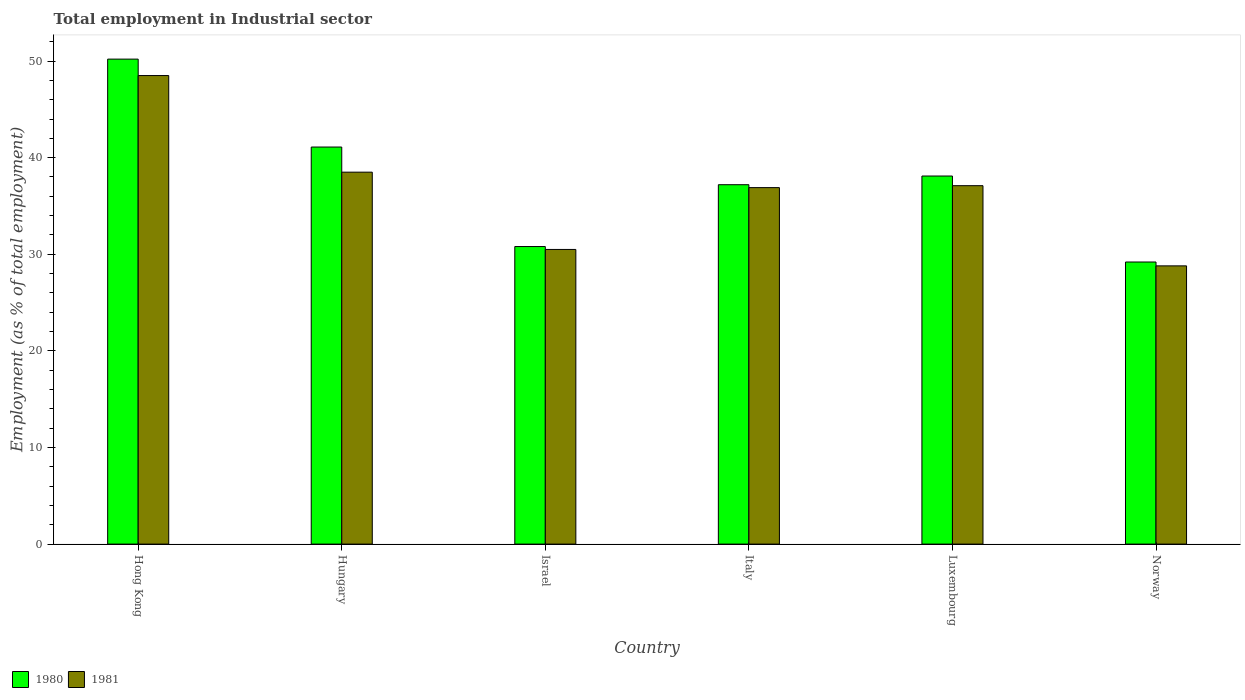How many different coloured bars are there?
Keep it short and to the point. 2. How many groups of bars are there?
Your response must be concise. 6. Are the number of bars per tick equal to the number of legend labels?
Your response must be concise. Yes. Are the number of bars on each tick of the X-axis equal?
Offer a very short reply. Yes. How many bars are there on the 6th tick from the left?
Your response must be concise. 2. How many bars are there on the 4th tick from the right?
Ensure brevity in your answer.  2. What is the employment in industrial sector in 1981 in Norway?
Offer a very short reply. 28.8. Across all countries, what is the maximum employment in industrial sector in 1980?
Provide a succinct answer. 50.2. Across all countries, what is the minimum employment in industrial sector in 1980?
Provide a short and direct response. 29.2. In which country was the employment in industrial sector in 1980 maximum?
Offer a very short reply. Hong Kong. In which country was the employment in industrial sector in 1981 minimum?
Make the answer very short. Norway. What is the total employment in industrial sector in 1980 in the graph?
Your answer should be compact. 226.6. What is the difference between the employment in industrial sector in 1981 in Hungary and that in Italy?
Make the answer very short. 1.6. What is the difference between the employment in industrial sector in 1980 in Luxembourg and the employment in industrial sector in 1981 in Norway?
Make the answer very short. 9.3. What is the average employment in industrial sector in 1980 per country?
Give a very brief answer. 37.77. What is the difference between the employment in industrial sector of/in 1981 and employment in industrial sector of/in 1980 in Hong Kong?
Give a very brief answer. -1.7. What is the ratio of the employment in industrial sector in 1981 in Israel to that in Luxembourg?
Your answer should be compact. 0.82. Is the employment in industrial sector in 1980 in Hungary less than that in Luxembourg?
Offer a terse response. No. Is the difference between the employment in industrial sector in 1981 in Italy and Norway greater than the difference between the employment in industrial sector in 1980 in Italy and Norway?
Provide a short and direct response. Yes. What is the difference between the highest and the second highest employment in industrial sector in 1980?
Make the answer very short. -9.1. What is the difference between the highest and the lowest employment in industrial sector in 1981?
Make the answer very short. 19.7. In how many countries, is the employment in industrial sector in 1981 greater than the average employment in industrial sector in 1981 taken over all countries?
Keep it short and to the point. 4. Is the sum of the employment in industrial sector in 1981 in Luxembourg and Norway greater than the maximum employment in industrial sector in 1980 across all countries?
Provide a succinct answer. Yes. What does the 2nd bar from the left in Italy represents?
Your answer should be very brief. 1981. Are all the bars in the graph horizontal?
Ensure brevity in your answer.  No. What is the difference between two consecutive major ticks on the Y-axis?
Keep it short and to the point. 10. Does the graph contain any zero values?
Your response must be concise. No. Where does the legend appear in the graph?
Your answer should be very brief. Bottom left. How many legend labels are there?
Your response must be concise. 2. How are the legend labels stacked?
Give a very brief answer. Horizontal. What is the title of the graph?
Offer a terse response. Total employment in Industrial sector. Does "1961" appear as one of the legend labels in the graph?
Provide a short and direct response. No. What is the label or title of the Y-axis?
Provide a short and direct response. Employment (as % of total employment). What is the Employment (as % of total employment) in 1980 in Hong Kong?
Your response must be concise. 50.2. What is the Employment (as % of total employment) in 1981 in Hong Kong?
Your answer should be compact. 48.5. What is the Employment (as % of total employment) of 1980 in Hungary?
Keep it short and to the point. 41.1. What is the Employment (as % of total employment) of 1981 in Hungary?
Provide a succinct answer. 38.5. What is the Employment (as % of total employment) of 1980 in Israel?
Provide a succinct answer. 30.8. What is the Employment (as % of total employment) in 1981 in Israel?
Offer a very short reply. 30.5. What is the Employment (as % of total employment) of 1980 in Italy?
Your response must be concise. 37.2. What is the Employment (as % of total employment) in 1981 in Italy?
Give a very brief answer. 36.9. What is the Employment (as % of total employment) in 1980 in Luxembourg?
Offer a terse response. 38.1. What is the Employment (as % of total employment) of 1981 in Luxembourg?
Your response must be concise. 37.1. What is the Employment (as % of total employment) in 1980 in Norway?
Keep it short and to the point. 29.2. What is the Employment (as % of total employment) of 1981 in Norway?
Provide a succinct answer. 28.8. Across all countries, what is the maximum Employment (as % of total employment) of 1980?
Keep it short and to the point. 50.2. Across all countries, what is the maximum Employment (as % of total employment) of 1981?
Provide a short and direct response. 48.5. Across all countries, what is the minimum Employment (as % of total employment) of 1980?
Give a very brief answer. 29.2. Across all countries, what is the minimum Employment (as % of total employment) in 1981?
Provide a short and direct response. 28.8. What is the total Employment (as % of total employment) of 1980 in the graph?
Offer a terse response. 226.6. What is the total Employment (as % of total employment) in 1981 in the graph?
Provide a short and direct response. 220.3. What is the difference between the Employment (as % of total employment) in 1981 in Hong Kong and that in Hungary?
Give a very brief answer. 10. What is the difference between the Employment (as % of total employment) of 1980 in Hong Kong and that in Israel?
Your answer should be compact. 19.4. What is the difference between the Employment (as % of total employment) in 1980 in Hong Kong and that in Italy?
Your answer should be compact. 13. What is the difference between the Employment (as % of total employment) in 1980 in Hong Kong and that in Luxembourg?
Give a very brief answer. 12.1. What is the difference between the Employment (as % of total employment) in 1981 in Hong Kong and that in Luxembourg?
Provide a short and direct response. 11.4. What is the difference between the Employment (as % of total employment) of 1980 in Hong Kong and that in Norway?
Make the answer very short. 21. What is the difference between the Employment (as % of total employment) of 1981 in Hungary and that in Israel?
Offer a terse response. 8. What is the difference between the Employment (as % of total employment) of 1980 in Hungary and that in Italy?
Your response must be concise. 3.9. What is the difference between the Employment (as % of total employment) of 1981 in Hungary and that in Italy?
Provide a short and direct response. 1.6. What is the difference between the Employment (as % of total employment) in 1981 in Hungary and that in Luxembourg?
Keep it short and to the point. 1.4. What is the difference between the Employment (as % of total employment) of 1981 in Israel and that in Italy?
Offer a terse response. -6.4. What is the difference between the Employment (as % of total employment) of 1980 in Israel and that in Luxembourg?
Give a very brief answer. -7.3. What is the difference between the Employment (as % of total employment) in 1981 in Israel and that in Luxembourg?
Your answer should be very brief. -6.6. What is the difference between the Employment (as % of total employment) in 1980 in Israel and that in Norway?
Your answer should be compact. 1.6. What is the difference between the Employment (as % of total employment) of 1981 in Israel and that in Norway?
Your answer should be very brief. 1.7. What is the difference between the Employment (as % of total employment) in 1980 in Italy and that in Norway?
Provide a succinct answer. 8. What is the difference between the Employment (as % of total employment) of 1981 in Italy and that in Norway?
Offer a terse response. 8.1. What is the difference between the Employment (as % of total employment) of 1980 in Luxembourg and that in Norway?
Keep it short and to the point. 8.9. What is the difference between the Employment (as % of total employment) of 1980 in Hong Kong and the Employment (as % of total employment) of 1981 in Hungary?
Your answer should be compact. 11.7. What is the difference between the Employment (as % of total employment) in 1980 in Hong Kong and the Employment (as % of total employment) in 1981 in Luxembourg?
Offer a very short reply. 13.1. What is the difference between the Employment (as % of total employment) in 1980 in Hong Kong and the Employment (as % of total employment) in 1981 in Norway?
Offer a very short reply. 21.4. What is the difference between the Employment (as % of total employment) of 1980 in Hungary and the Employment (as % of total employment) of 1981 in Luxembourg?
Provide a succinct answer. 4. What is the difference between the Employment (as % of total employment) of 1980 in Hungary and the Employment (as % of total employment) of 1981 in Norway?
Offer a very short reply. 12.3. What is the difference between the Employment (as % of total employment) of 1980 in Israel and the Employment (as % of total employment) of 1981 in Luxembourg?
Ensure brevity in your answer.  -6.3. What is the difference between the Employment (as % of total employment) in 1980 in Luxembourg and the Employment (as % of total employment) in 1981 in Norway?
Your answer should be very brief. 9.3. What is the average Employment (as % of total employment) of 1980 per country?
Make the answer very short. 37.77. What is the average Employment (as % of total employment) in 1981 per country?
Make the answer very short. 36.72. What is the difference between the Employment (as % of total employment) in 1980 and Employment (as % of total employment) in 1981 in Luxembourg?
Offer a very short reply. 1. What is the difference between the Employment (as % of total employment) of 1980 and Employment (as % of total employment) of 1981 in Norway?
Provide a succinct answer. 0.4. What is the ratio of the Employment (as % of total employment) of 1980 in Hong Kong to that in Hungary?
Your response must be concise. 1.22. What is the ratio of the Employment (as % of total employment) of 1981 in Hong Kong to that in Hungary?
Make the answer very short. 1.26. What is the ratio of the Employment (as % of total employment) in 1980 in Hong Kong to that in Israel?
Keep it short and to the point. 1.63. What is the ratio of the Employment (as % of total employment) in 1981 in Hong Kong to that in Israel?
Keep it short and to the point. 1.59. What is the ratio of the Employment (as % of total employment) in 1980 in Hong Kong to that in Italy?
Offer a very short reply. 1.35. What is the ratio of the Employment (as % of total employment) of 1981 in Hong Kong to that in Italy?
Your answer should be compact. 1.31. What is the ratio of the Employment (as % of total employment) of 1980 in Hong Kong to that in Luxembourg?
Offer a terse response. 1.32. What is the ratio of the Employment (as % of total employment) of 1981 in Hong Kong to that in Luxembourg?
Your answer should be very brief. 1.31. What is the ratio of the Employment (as % of total employment) in 1980 in Hong Kong to that in Norway?
Provide a succinct answer. 1.72. What is the ratio of the Employment (as % of total employment) in 1981 in Hong Kong to that in Norway?
Give a very brief answer. 1.68. What is the ratio of the Employment (as % of total employment) in 1980 in Hungary to that in Israel?
Provide a short and direct response. 1.33. What is the ratio of the Employment (as % of total employment) of 1981 in Hungary to that in Israel?
Your response must be concise. 1.26. What is the ratio of the Employment (as % of total employment) in 1980 in Hungary to that in Italy?
Ensure brevity in your answer.  1.1. What is the ratio of the Employment (as % of total employment) in 1981 in Hungary to that in Italy?
Keep it short and to the point. 1.04. What is the ratio of the Employment (as % of total employment) of 1980 in Hungary to that in Luxembourg?
Offer a very short reply. 1.08. What is the ratio of the Employment (as % of total employment) in 1981 in Hungary to that in Luxembourg?
Give a very brief answer. 1.04. What is the ratio of the Employment (as % of total employment) of 1980 in Hungary to that in Norway?
Keep it short and to the point. 1.41. What is the ratio of the Employment (as % of total employment) of 1981 in Hungary to that in Norway?
Provide a succinct answer. 1.34. What is the ratio of the Employment (as % of total employment) in 1980 in Israel to that in Italy?
Provide a short and direct response. 0.83. What is the ratio of the Employment (as % of total employment) of 1981 in Israel to that in Italy?
Provide a short and direct response. 0.83. What is the ratio of the Employment (as % of total employment) of 1980 in Israel to that in Luxembourg?
Your answer should be very brief. 0.81. What is the ratio of the Employment (as % of total employment) in 1981 in Israel to that in Luxembourg?
Keep it short and to the point. 0.82. What is the ratio of the Employment (as % of total employment) in 1980 in Israel to that in Norway?
Your response must be concise. 1.05. What is the ratio of the Employment (as % of total employment) in 1981 in Israel to that in Norway?
Provide a succinct answer. 1.06. What is the ratio of the Employment (as % of total employment) of 1980 in Italy to that in Luxembourg?
Provide a short and direct response. 0.98. What is the ratio of the Employment (as % of total employment) of 1980 in Italy to that in Norway?
Give a very brief answer. 1.27. What is the ratio of the Employment (as % of total employment) in 1981 in Italy to that in Norway?
Offer a terse response. 1.28. What is the ratio of the Employment (as % of total employment) in 1980 in Luxembourg to that in Norway?
Make the answer very short. 1.3. What is the ratio of the Employment (as % of total employment) of 1981 in Luxembourg to that in Norway?
Provide a succinct answer. 1.29. What is the difference between the highest and the lowest Employment (as % of total employment) in 1980?
Make the answer very short. 21. What is the difference between the highest and the lowest Employment (as % of total employment) of 1981?
Provide a succinct answer. 19.7. 